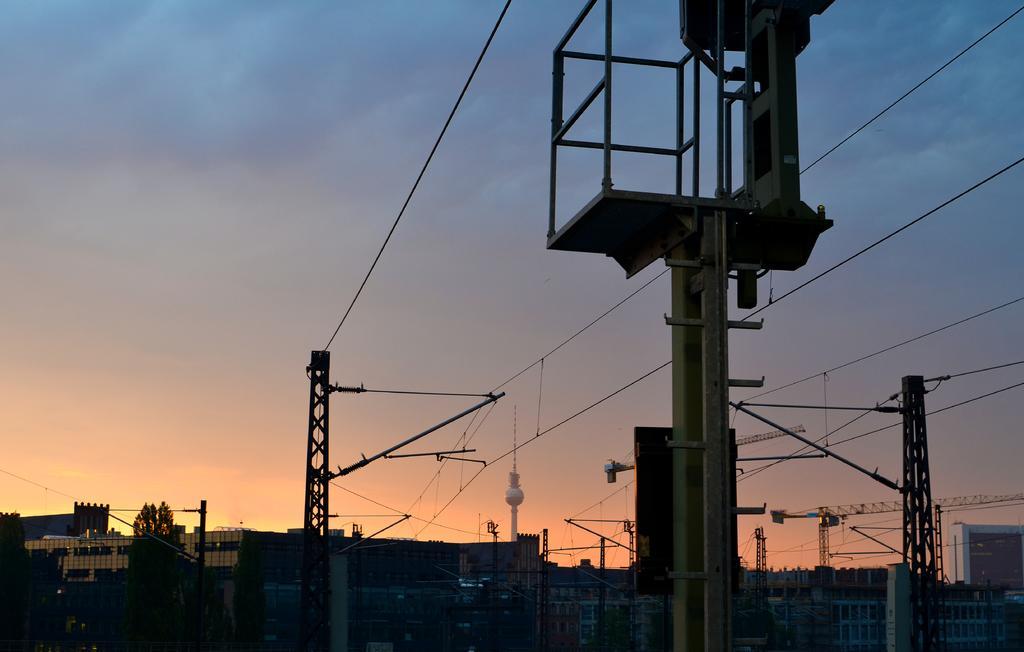How would you summarize this image in a sentence or two? In the image there are many current poles and in between those poles there are some buildings and on the left side there are few trees. 